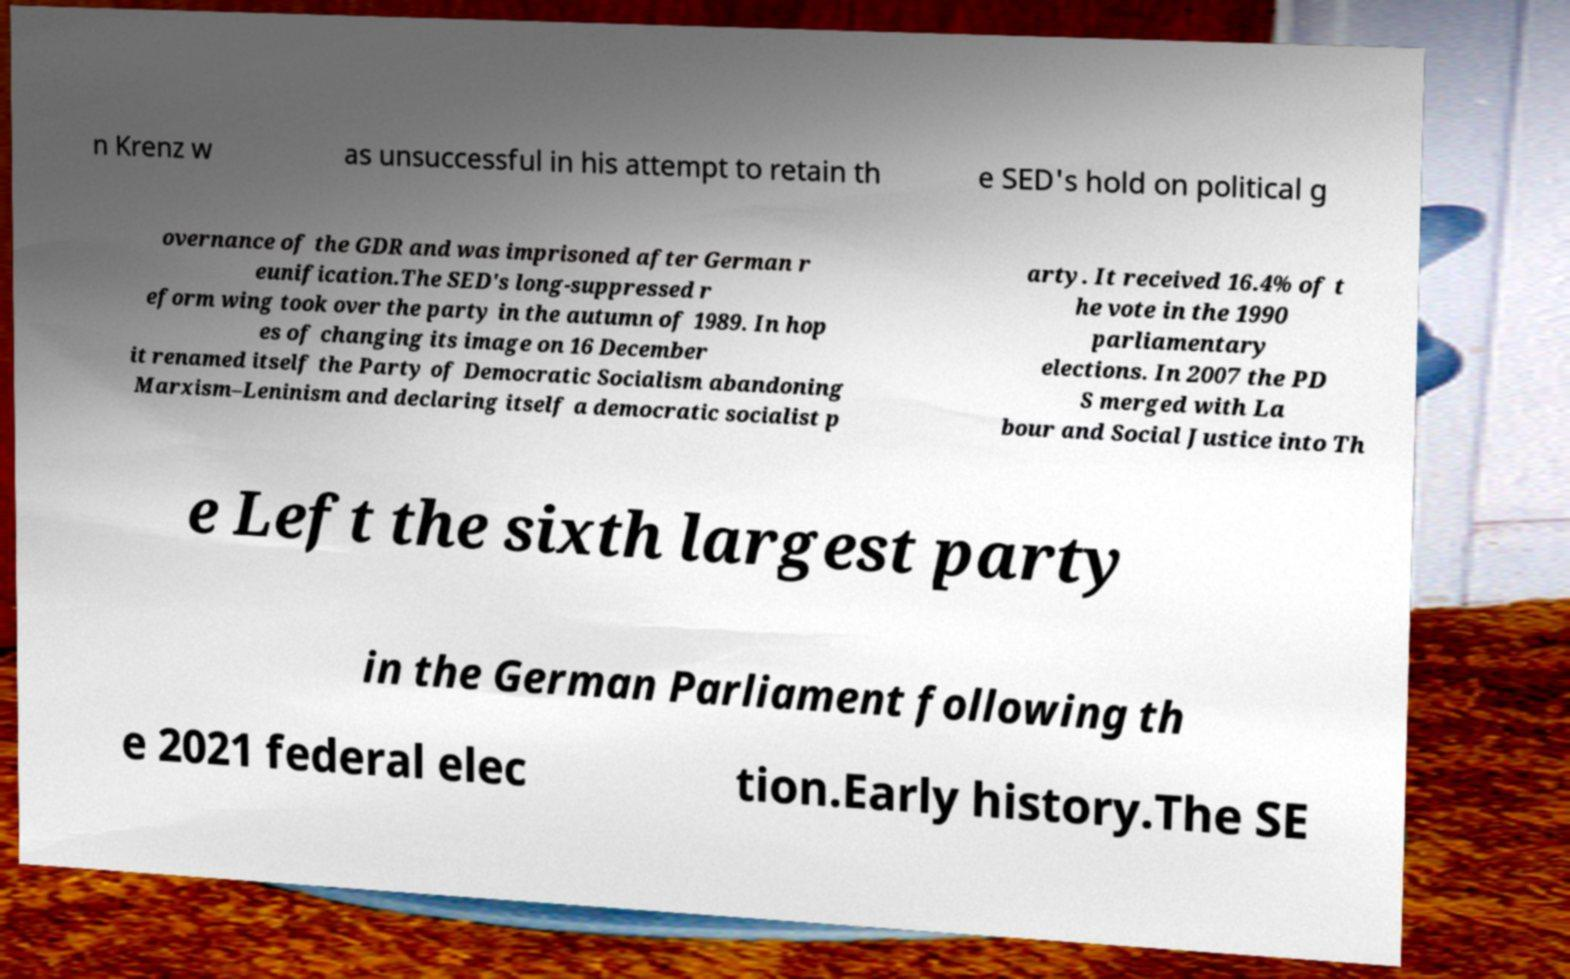Please identify and transcribe the text found in this image. n Krenz w as unsuccessful in his attempt to retain th e SED's hold on political g overnance of the GDR and was imprisoned after German r eunification.The SED's long-suppressed r eform wing took over the party in the autumn of 1989. In hop es of changing its image on 16 December it renamed itself the Party of Democratic Socialism abandoning Marxism–Leninism and declaring itself a democratic socialist p arty. It received 16.4% of t he vote in the 1990 parliamentary elections. In 2007 the PD S merged with La bour and Social Justice into Th e Left the sixth largest party in the German Parliament following th e 2021 federal elec tion.Early history.The SE 